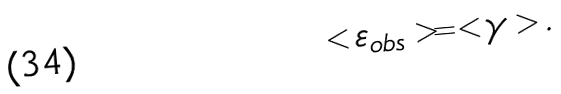<formula> <loc_0><loc_0><loc_500><loc_500>< \varepsilon _ { o b s } > = < \gamma > .</formula> 